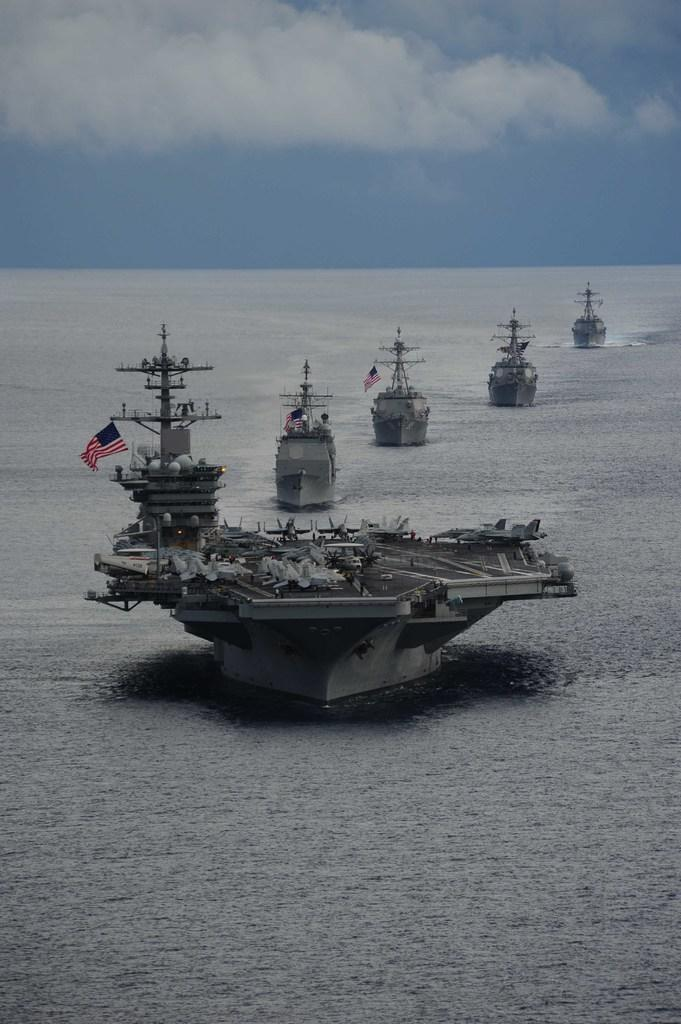What is the main subject of the image? The main subject of the image is ships. What can be inferred about the location of the ships? The ships are sailing in the ocean. What is the color of the ships? The ships are grey in color. What is visible in the background of the image? There is a sky visible in the background of the image. What can be observed about the sky in the image? There are clouds in the sky. What type of books can be seen on the ships in the image? There are no books visible in the image; it features ships sailing in the ocean. Are the police officers present on the ships in the image? There is no indication of police officers or any law enforcement personnel in the image. 